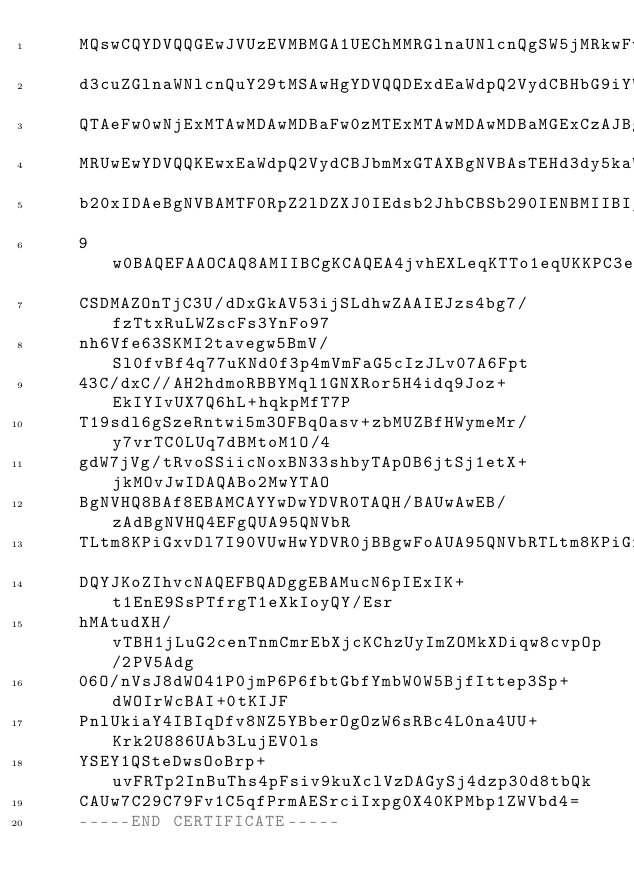Convert code to text. <code><loc_0><loc_0><loc_500><loc_500><_YAML_>    MQswCQYDVQQGEwJVUzEVMBMGA1UEChMMRGlnaUNlcnQgSW5jMRkwFwYDVQQLExB3
    d3cuZGlnaWNlcnQuY29tMSAwHgYDVQQDExdEaWdpQ2VydCBHbG9iYWwgUm9vdCBD
    QTAeFw0wNjExMTAwMDAwMDBaFw0zMTExMTAwMDAwMDBaMGExCzAJBgNVBAYTAlVT
    MRUwEwYDVQQKEwxEaWdpQ2VydCBJbmMxGTAXBgNVBAsTEHd3dy5kaWdpY2VydC5j
    b20xIDAeBgNVBAMTF0RpZ2lDZXJ0IEdsb2JhbCBSb290IENBMIIBIjANBgkqhkiG
    9w0BAQEFAAOCAQ8AMIIBCgKCAQEA4jvhEXLeqKTTo1eqUKKPC3eQyaKl7hLOllsB
    CSDMAZOnTjC3U/dDxGkAV53ijSLdhwZAAIEJzs4bg7/fzTtxRuLWZscFs3YnFo97
    nh6Vfe63SKMI2tavegw5BmV/Sl0fvBf4q77uKNd0f3p4mVmFaG5cIzJLv07A6Fpt
    43C/dxC//AH2hdmoRBBYMql1GNXRor5H4idq9Joz+EkIYIvUX7Q6hL+hqkpMfT7P
    T19sdl6gSzeRntwi5m3OFBqOasv+zbMUZBfHWymeMr/y7vrTC0LUq7dBMtoM1O/4
    gdW7jVg/tRvoSSiicNoxBN33shbyTApOB6jtSj1etX+jkMOvJwIDAQABo2MwYTAO
    BgNVHQ8BAf8EBAMCAYYwDwYDVR0TAQH/BAUwAwEB/zAdBgNVHQ4EFgQUA95QNVbR
    TLtm8KPiGxvDl7I90VUwHwYDVR0jBBgwFoAUA95QNVbRTLtm8KPiGxvDl7I90VUw
    DQYJKoZIhvcNAQEFBQADggEBAMucN6pIExIK+t1EnE9SsPTfrgT1eXkIoyQY/Esr
    hMAtudXH/vTBH1jLuG2cenTnmCmrEbXjcKChzUyImZOMkXDiqw8cvpOp/2PV5Adg
    06O/nVsJ8dWO41P0jmP6P6fbtGbfYmbW0W5BjfIttep3Sp+dWOIrWcBAI+0tKIJF
    PnlUkiaY4IBIqDfv8NZ5YBberOgOzW6sRBc4L0na4UU+Krk2U886UAb3LujEV0ls
    YSEY1QSteDwsOoBrp+uvFRTp2InBuThs4pFsiv9kuXclVzDAGySj4dzp30d8tbQk
    CAUw7C29C79Fv1C5qfPrmAESrciIxpg0X40KPMbp1ZWVbd4=
    -----END CERTIFICATE-----
</code> 